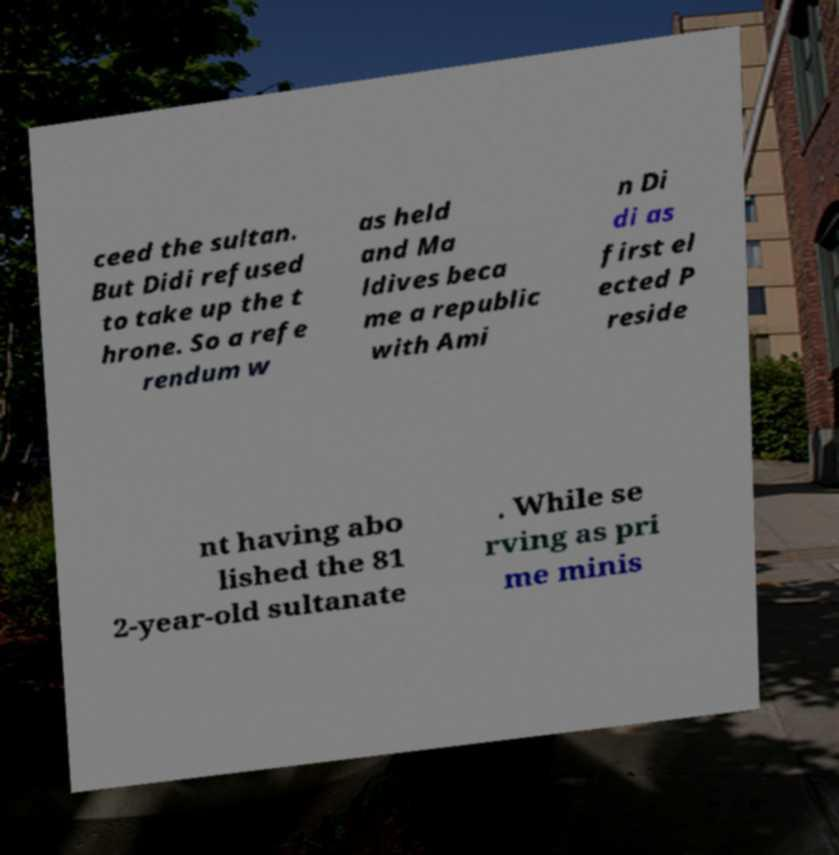Please read and relay the text visible in this image. What does it say? ceed the sultan. But Didi refused to take up the t hrone. So a refe rendum w as held and Ma ldives beca me a republic with Ami n Di di as first el ected P reside nt having abo lished the 81 2-year-old sultanate . While se rving as pri me minis 